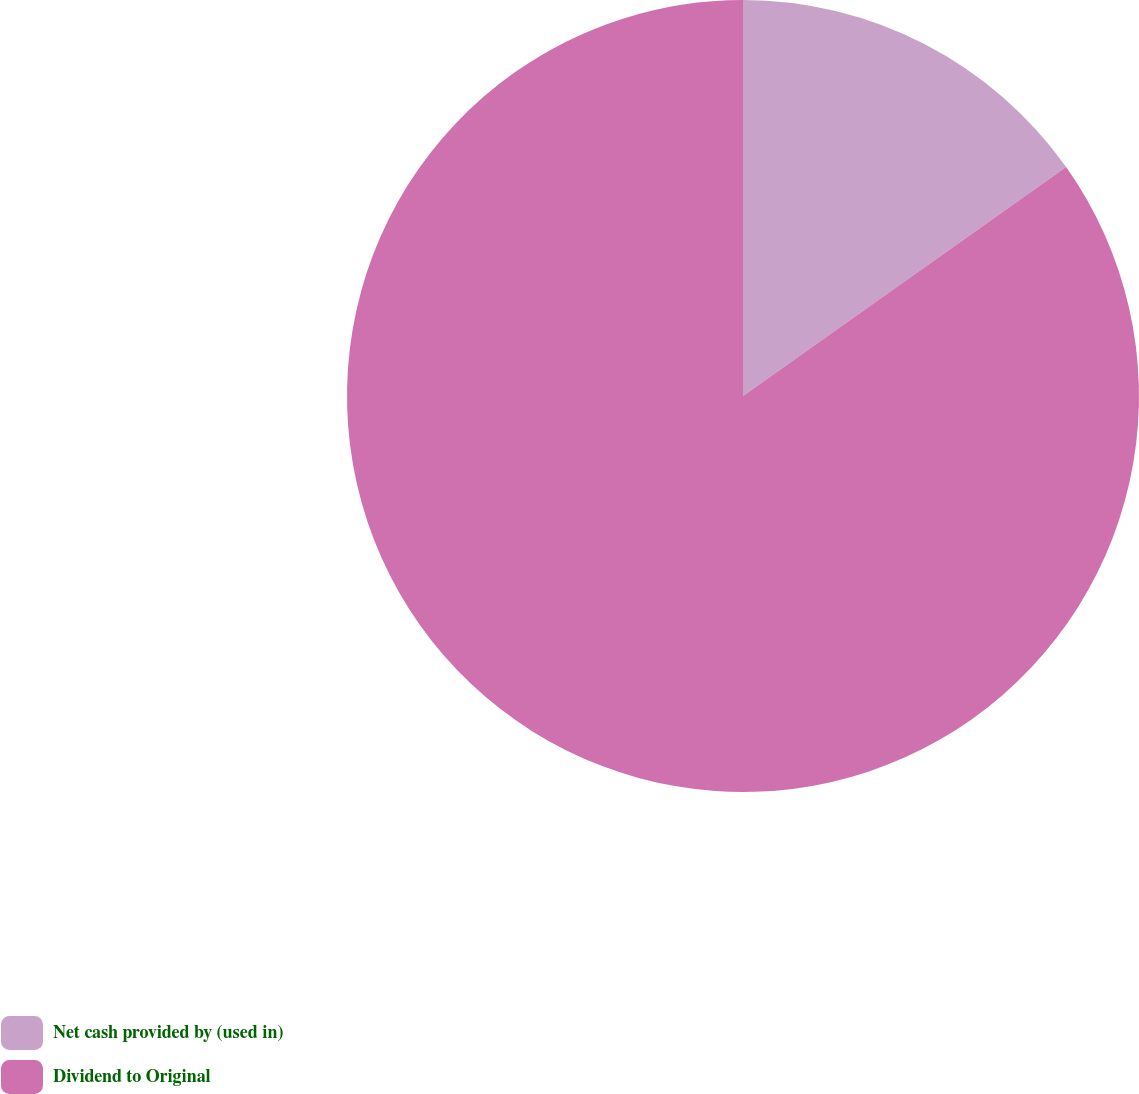<chart> <loc_0><loc_0><loc_500><loc_500><pie_chart><fcel>Net cash provided by (used in)<fcel>Dividend to Original<nl><fcel>15.19%<fcel>84.81%<nl></chart> 